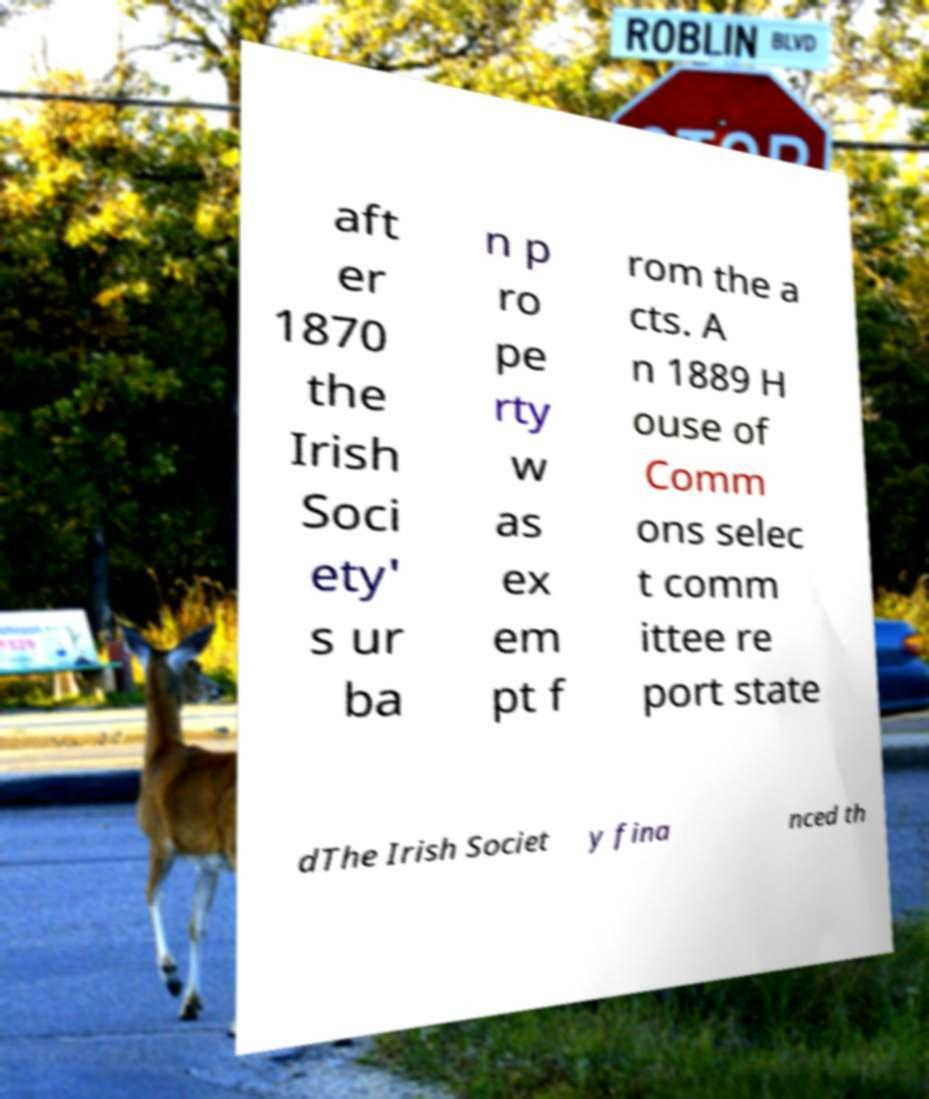Please read and relay the text visible in this image. What does it say? aft er 1870 the Irish Soci ety' s ur ba n p ro pe rty w as ex em pt f rom the a cts. A n 1889 H ouse of Comm ons selec t comm ittee re port state dThe Irish Societ y fina nced th 